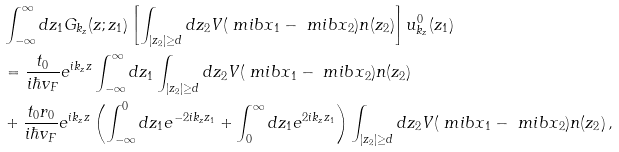Convert formula to latex. <formula><loc_0><loc_0><loc_500><loc_500>& \int _ { - \infty } ^ { \infty } d z _ { 1 } G _ { k _ { z } } ( z ; z _ { 1 } ) \left [ \int _ { | z _ { 2 } | \geq d } d z _ { 2 } V ( \ m i b { x } _ { 1 } - \ m i b { x } _ { 2 } ) n ( z _ { 2 } ) \right ] u _ { k _ { z } } ^ { 0 } ( z _ { 1 } ) \\ & = \frac { t _ { 0 } } { i \hbar { v } _ { F } } e ^ { i k _ { z } z } \int _ { - \infty } ^ { \infty } d z _ { 1 } \int _ { | z _ { 2 } | \geq d } d z _ { 2 } V ( \ m i b { x } _ { 1 } - \ m i b { x } _ { 2 } ) n ( z _ { 2 } ) \\ & + \frac { t _ { 0 } r _ { 0 } } { i \hbar { v } _ { F } } e ^ { i k _ { z } z } \left ( \int _ { - \infty } ^ { 0 } d z _ { 1 } e ^ { - 2 i k _ { z } z _ { 1 } } + \int _ { 0 } ^ { \infty } d z _ { 1 } e ^ { 2 i k _ { z } z _ { 1 } } \right ) \int _ { | z _ { 2 } | \geq d } d z _ { 2 } V ( \ m i b { x } _ { 1 } - \ m i b { x } _ { 2 } ) n ( z _ { 2 } ) \, ,</formula> 